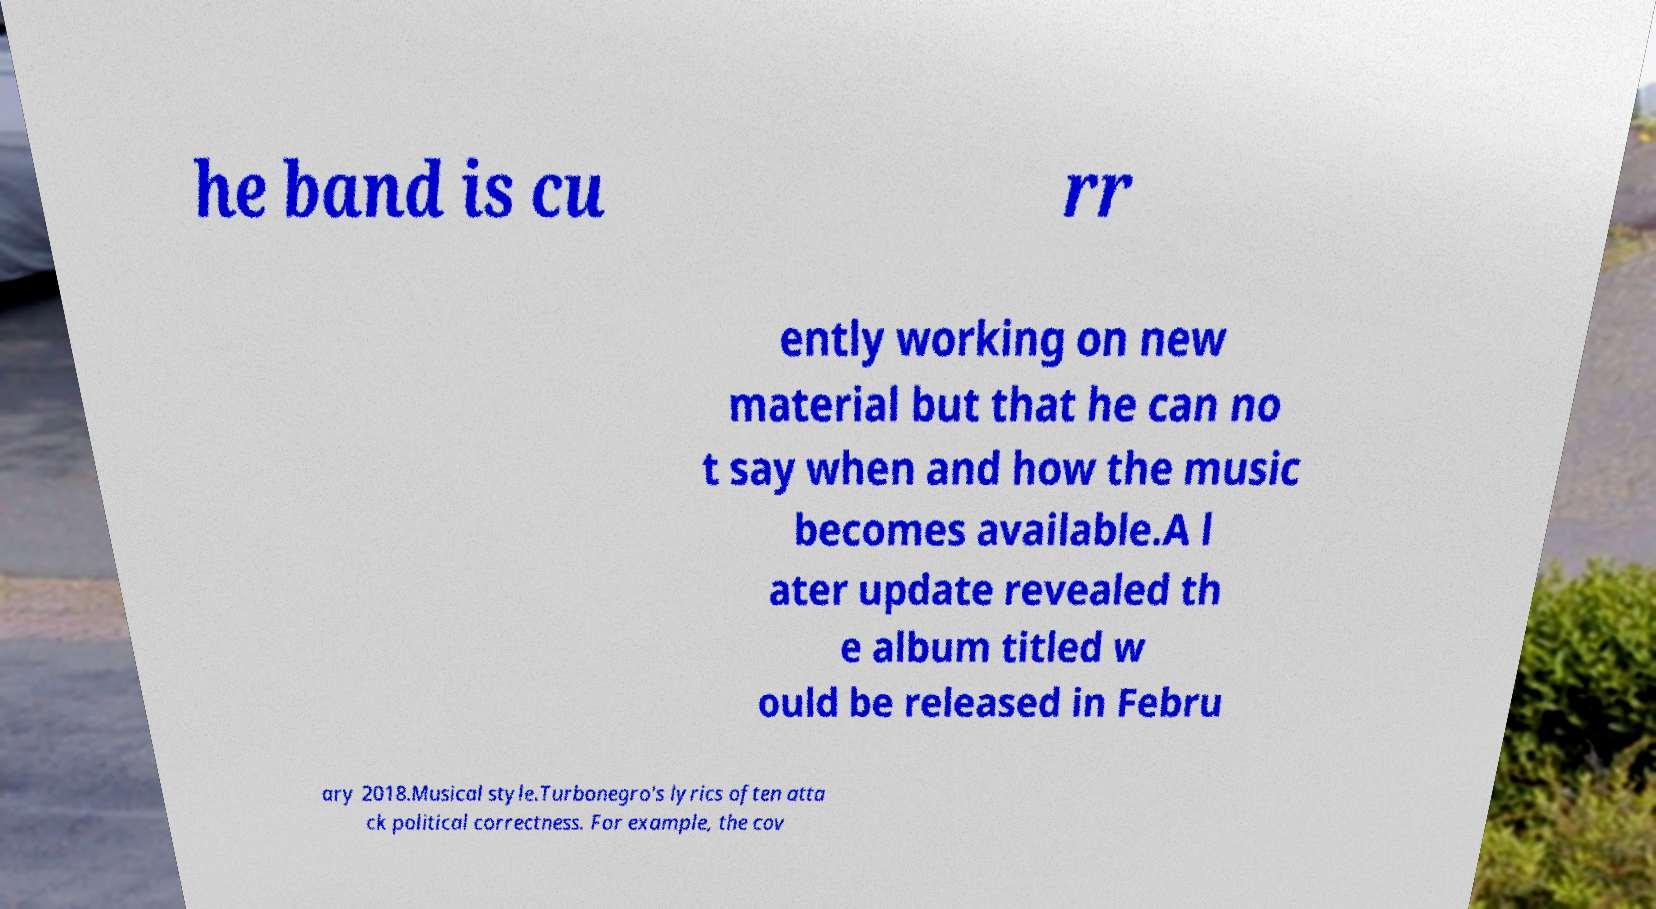Could you assist in decoding the text presented in this image and type it out clearly? he band is cu rr ently working on new material but that he can no t say when and how the music becomes available.A l ater update revealed th e album titled w ould be released in Febru ary 2018.Musical style.Turbonegro's lyrics often atta ck political correctness. For example, the cov 